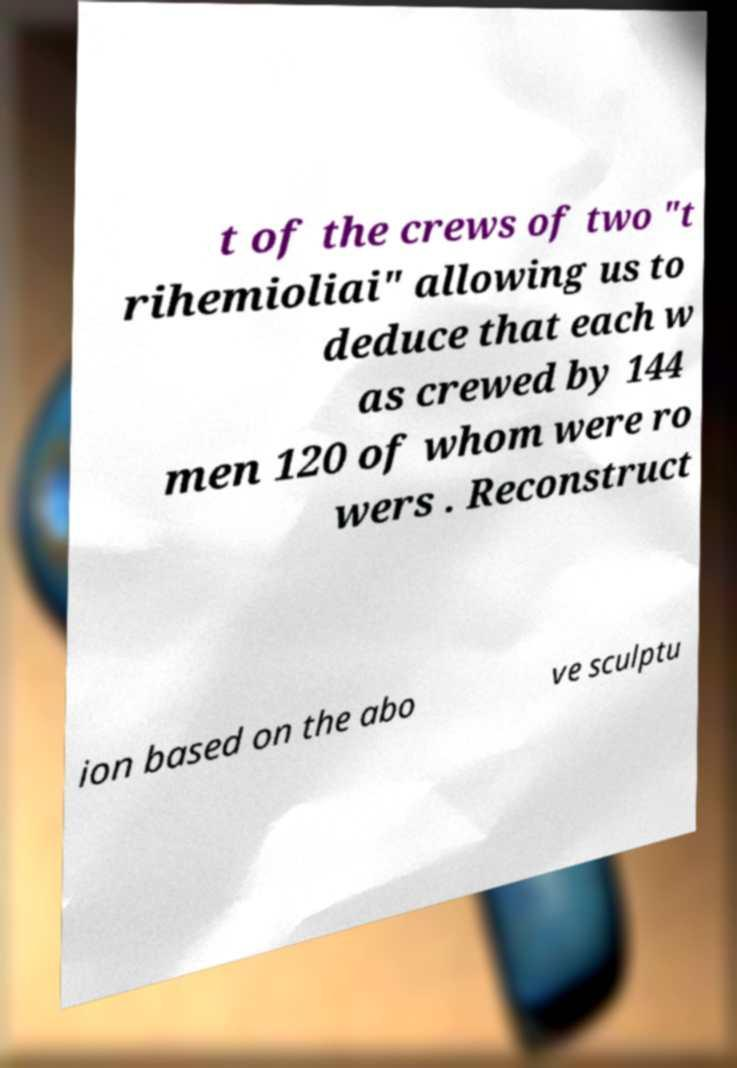Can you accurately transcribe the text from the provided image for me? t of the crews of two "t rihemioliai" allowing us to deduce that each w as crewed by 144 men 120 of whom were ro wers . Reconstruct ion based on the abo ve sculptu 